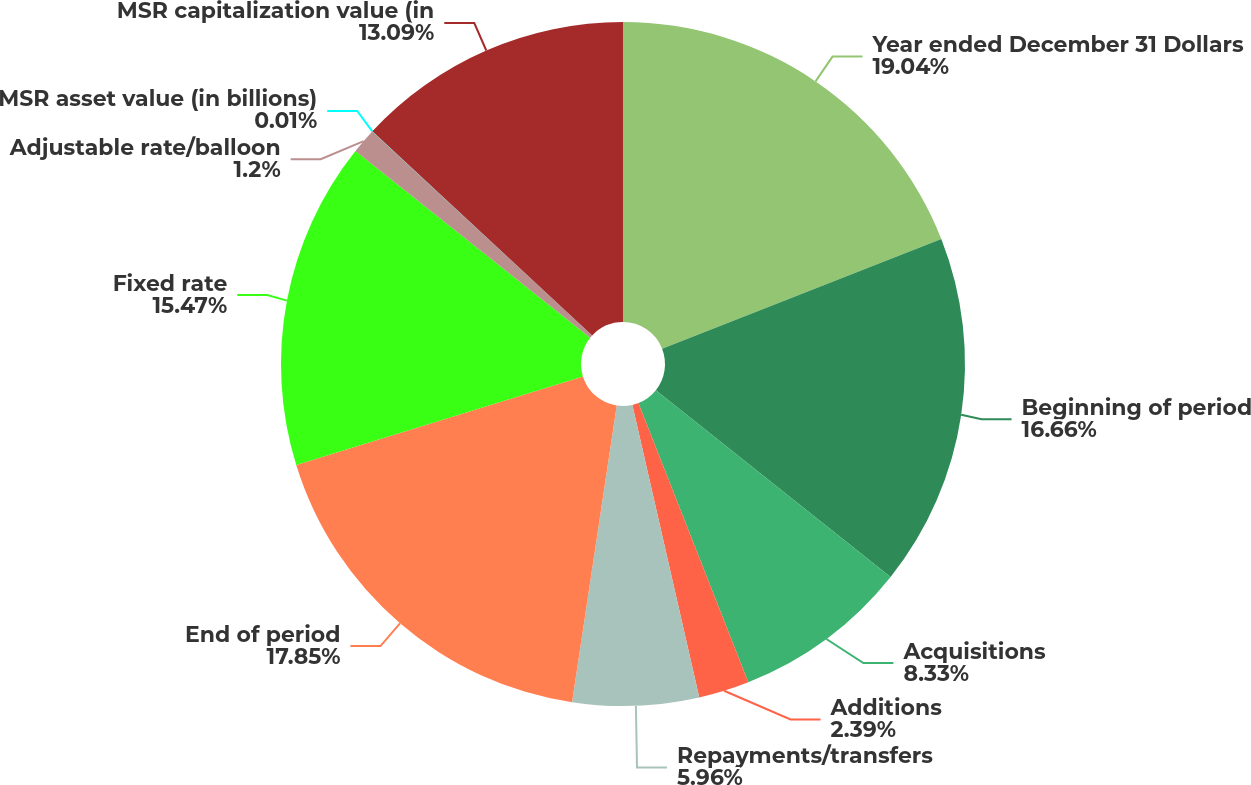Convert chart to OTSL. <chart><loc_0><loc_0><loc_500><loc_500><pie_chart><fcel>Year ended December 31 Dollars<fcel>Beginning of period<fcel>Acquisitions<fcel>Additions<fcel>Repayments/transfers<fcel>End of period<fcel>Fixed rate<fcel>Adjustable rate/balloon<fcel>MSR asset value (in billions)<fcel>MSR capitalization value (in<nl><fcel>19.04%<fcel>16.66%<fcel>8.33%<fcel>2.39%<fcel>5.96%<fcel>17.85%<fcel>15.47%<fcel>1.2%<fcel>0.01%<fcel>13.09%<nl></chart> 